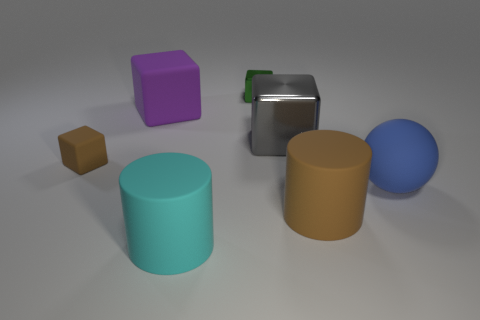Subtract all tiny brown cubes. How many cubes are left? 3 Add 2 big brown matte things. How many objects exist? 9 Subtract all big cyan matte objects. Subtract all tiny brown cubes. How many objects are left? 5 Add 5 large blue rubber balls. How many large blue rubber balls are left? 6 Add 4 metallic cubes. How many metallic cubes exist? 6 Subtract all brown cylinders. How many cylinders are left? 1 Subtract 1 gray cubes. How many objects are left? 6 Subtract all spheres. How many objects are left? 6 Subtract 1 cubes. How many cubes are left? 3 Subtract all gray spheres. Subtract all yellow cubes. How many spheres are left? 1 